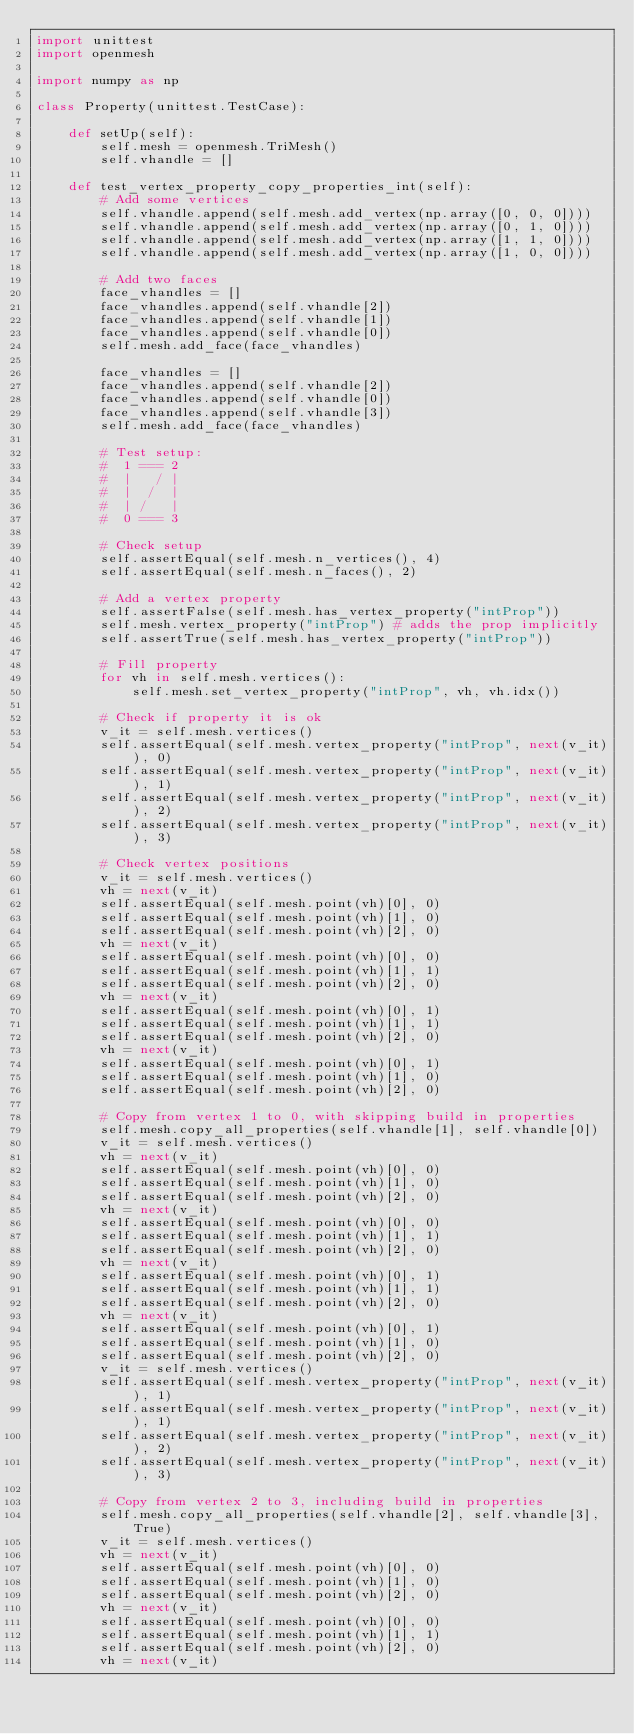Convert code to text. <code><loc_0><loc_0><loc_500><loc_500><_Python_>import unittest
import openmesh

import numpy as np

class Property(unittest.TestCase):

    def setUp(self):
        self.mesh = openmesh.TriMesh()
        self.vhandle = []

    def test_vertex_property_copy_properties_int(self):
        # Add some vertices
        self.vhandle.append(self.mesh.add_vertex(np.array([0, 0, 0])))
        self.vhandle.append(self.mesh.add_vertex(np.array([0, 1, 0])))
        self.vhandle.append(self.mesh.add_vertex(np.array([1, 1, 0])))
        self.vhandle.append(self.mesh.add_vertex(np.array([1, 0, 0])))
        
        # Add two faces
        face_vhandles = []
        face_vhandles.append(self.vhandle[2])
        face_vhandles.append(self.vhandle[1])
        face_vhandles.append(self.vhandle[0])
        self.mesh.add_face(face_vhandles)
        
        face_vhandles = []
        face_vhandles.append(self.vhandle[2])
        face_vhandles.append(self.vhandle[0])
        face_vhandles.append(self.vhandle[3])
        self.mesh.add_face(face_vhandles)
        
        # Test setup:
        #  1 === 2
        #  |   / |
        #  |  /  |
        #  | /   |
        #  0 === 3
        
        # Check setup
        self.assertEqual(self.mesh.n_vertices(), 4)
        self.assertEqual(self.mesh.n_faces(), 2)
        
        # Add a vertex property
        self.assertFalse(self.mesh.has_vertex_property("intProp"))
        self.mesh.vertex_property("intProp") # adds the prop implicitly
        self.assertTrue(self.mesh.has_vertex_property("intProp"))
        
        # Fill property
        for vh in self.mesh.vertices():
            self.mesh.set_vertex_property("intProp", vh, vh.idx())
        
        # Check if property it is ok
        v_it = self.mesh.vertices()
        self.assertEqual(self.mesh.vertex_property("intProp", next(v_it)), 0)
        self.assertEqual(self.mesh.vertex_property("intProp", next(v_it)), 1)
        self.assertEqual(self.mesh.vertex_property("intProp", next(v_it)), 2)
        self.assertEqual(self.mesh.vertex_property("intProp", next(v_it)), 3)
        
        # Check vertex positions
        v_it = self.mesh.vertices()
        vh = next(v_it)
        self.assertEqual(self.mesh.point(vh)[0], 0)
        self.assertEqual(self.mesh.point(vh)[1], 0)
        self.assertEqual(self.mesh.point(vh)[2], 0)
        vh = next(v_it)
        self.assertEqual(self.mesh.point(vh)[0], 0)
        self.assertEqual(self.mesh.point(vh)[1], 1)
        self.assertEqual(self.mesh.point(vh)[2], 0)
        vh = next(v_it)
        self.assertEqual(self.mesh.point(vh)[0], 1)
        self.assertEqual(self.mesh.point(vh)[1], 1)
        self.assertEqual(self.mesh.point(vh)[2], 0)
        vh = next(v_it)
        self.assertEqual(self.mesh.point(vh)[0], 1)
        self.assertEqual(self.mesh.point(vh)[1], 0)
        self.assertEqual(self.mesh.point(vh)[2], 0)
        
        # Copy from vertex 1 to 0, with skipping build in properties
        self.mesh.copy_all_properties(self.vhandle[1], self.vhandle[0])
        v_it = self.mesh.vertices()
        vh = next(v_it)
        self.assertEqual(self.mesh.point(vh)[0], 0)
        self.assertEqual(self.mesh.point(vh)[1], 0)
        self.assertEqual(self.mesh.point(vh)[2], 0)
        vh = next(v_it)
        self.assertEqual(self.mesh.point(vh)[0], 0)
        self.assertEqual(self.mesh.point(vh)[1], 1)
        self.assertEqual(self.mesh.point(vh)[2], 0)
        vh = next(v_it)
        self.assertEqual(self.mesh.point(vh)[0], 1)
        self.assertEqual(self.mesh.point(vh)[1], 1)
        self.assertEqual(self.mesh.point(vh)[2], 0)
        vh = next(v_it)
        self.assertEqual(self.mesh.point(vh)[0], 1)
        self.assertEqual(self.mesh.point(vh)[1], 0)
        self.assertEqual(self.mesh.point(vh)[2], 0)
        v_it = self.mesh.vertices()
        self.assertEqual(self.mesh.vertex_property("intProp", next(v_it)), 1)
        self.assertEqual(self.mesh.vertex_property("intProp", next(v_it)), 1)
        self.assertEqual(self.mesh.vertex_property("intProp", next(v_it)), 2)
        self.assertEqual(self.mesh.vertex_property("intProp", next(v_it)), 3)

        # Copy from vertex 2 to 3, including build in properties
        self.mesh.copy_all_properties(self.vhandle[2], self.vhandle[3], True)
        v_it = self.mesh.vertices()
        vh = next(v_it)
        self.assertEqual(self.mesh.point(vh)[0], 0)
        self.assertEqual(self.mesh.point(vh)[1], 0)
        self.assertEqual(self.mesh.point(vh)[2], 0)
        vh = next(v_it)
        self.assertEqual(self.mesh.point(vh)[0], 0)
        self.assertEqual(self.mesh.point(vh)[1], 1)
        self.assertEqual(self.mesh.point(vh)[2], 0)
        vh = next(v_it)</code> 